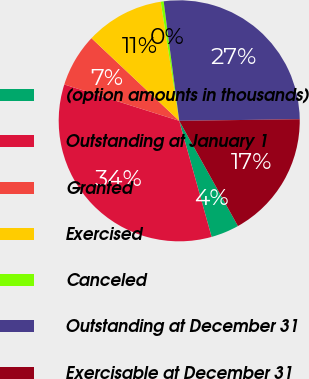Convert chart to OTSL. <chart><loc_0><loc_0><loc_500><loc_500><pie_chart><fcel>(option amounts in thousands)<fcel>Outstanding at January 1<fcel>Granted<fcel>Exercised<fcel>Canceled<fcel>Outstanding at December 31<fcel>Exercisable at December 31<nl><fcel>3.77%<fcel>34.21%<fcel>7.15%<fcel>10.53%<fcel>0.39%<fcel>26.85%<fcel>17.11%<nl></chart> 